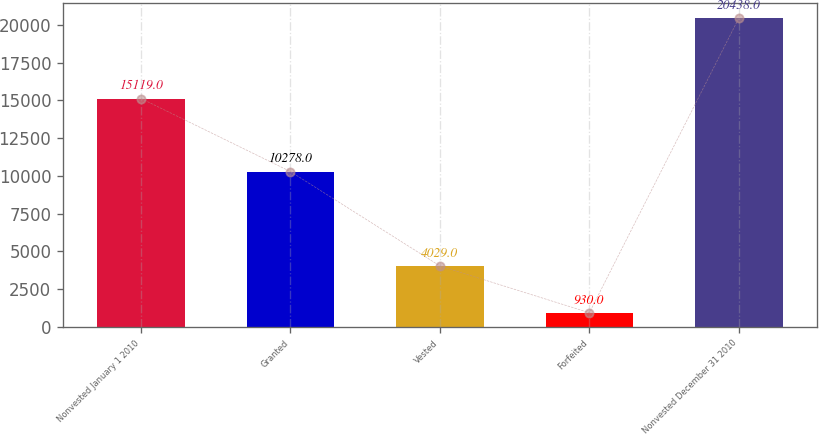Convert chart to OTSL. <chart><loc_0><loc_0><loc_500><loc_500><bar_chart><fcel>Nonvested January 1 2010<fcel>Granted<fcel>Vested<fcel>Forfeited<fcel>Nonvested December 31 2010<nl><fcel>15119<fcel>10278<fcel>4029<fcel>930<fcel>20438<nl></chart> 